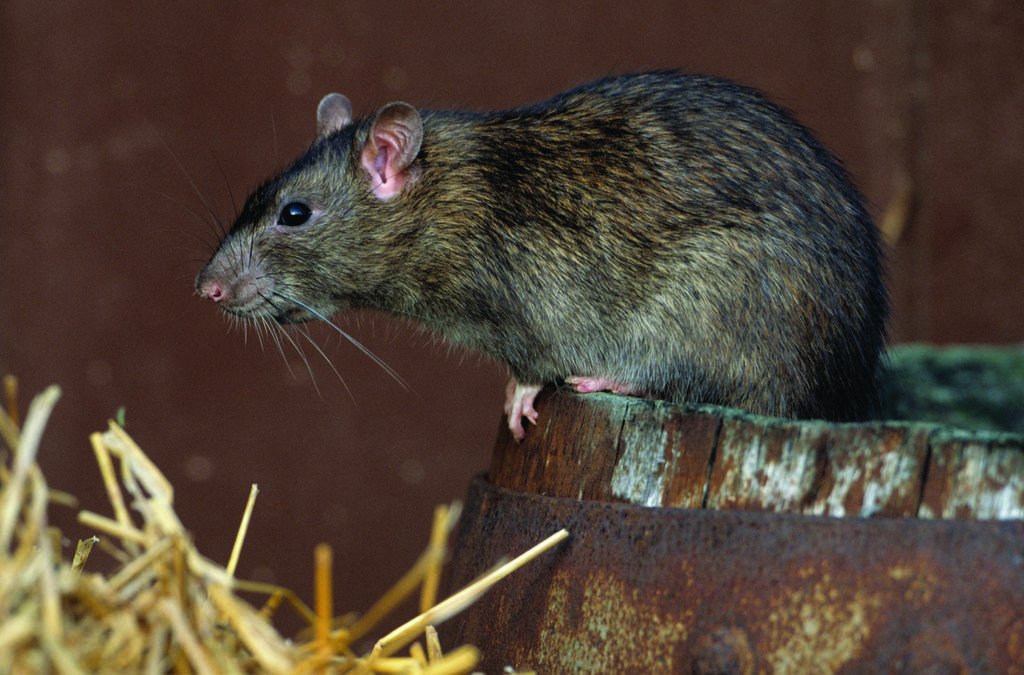What animal can be seen in the image? There is a rat in the image. Where is the rat located in the image? The rat is on a path in the image. What type of vegetation is near the path in the image? There is dry grass near the path in the image. How many coats is the rat wearing in the image? The rat is not wearing any coats in the image, as rats do not wear clothing. 